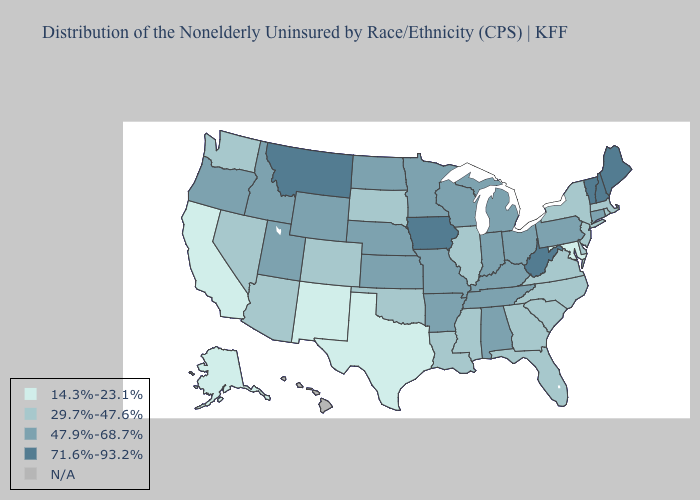What is the lowest value in the West?
Give a very brief answer. 14.3%-23.1%. What is the highest value in the Northeast ?
Answer briefly. 71.6%-93.2%. Which states have the highest value in the USA?
Write a very short answer. Iowa, Maine, Montana, New Hampshire, Vermont, West Virginia. Does West Virginia have the highest value in the South?
Short answer required. Yes. Does Maryland have the lowest value in the USA?
Write a very short answer. Yes. Is the legend a continuous bar?
Give a very brief answer. No. What is the value of Oregon?
Short answer required. 47.9%-68.7%. What is the lowest value in the USA?
Short answer required. 14.3%-23.1%. Does Texas have the lowest value in the USA?
Give a very brief answer. Yes. Name the states that have a value in the range N/A?
Write a very short answer. Hawaii. Does North Carolina have the lowest value in the South?
Give a very brief answer. No. Does Georgia have the highest value in the South?
Be succinct. No. Name the states that have a value in the range 14.3%-23.1%?
Quick response, please. Alaska, California, Maryland, New Mexico, Texas. Name the states that have a value in the range 71.6%-93.2%?
Give a very brief answer. Iowa, Maine, Montana, New Hampshire, Vermont, West Virginia. 